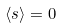<formula> <loc_0><loc_0><loc_500><loc_500>\langle s \rangle = 0</formula> 